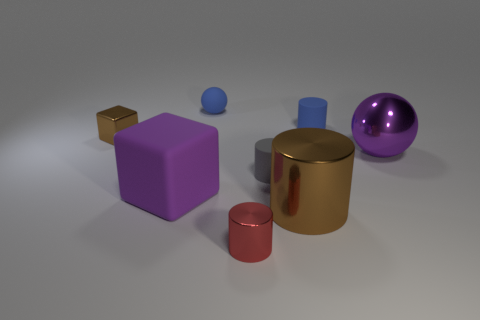Subtract 2 cylinders. How many cylinders are left? 2 Add 2 large shiny cylinders. How many objects exist? 10 Subtract all blocks. How many objects are left? 6 Subtract 1 red cylinders. How many objects are left? 7 Subtract all small red metallic things. Subtract all brown metallic blocks. How many objects are left? 6 Add 8 small blue spheres. How many small blue spheres are left? 9 Add 4 metal spheres. How many metal spheres exist? 5 